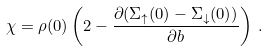Convert formula to latex. <formula><loc_0><loc_0><loc_500><loc_500>\chi = \rho ( 0 ) \left ( 2 - \frac { \partial ( \Sigma _ { \uparrow } ( 0 ) - \Sigma _ { \downarrow } ( 0 ) ) } { \partial b } \right ) \, .</formula> 